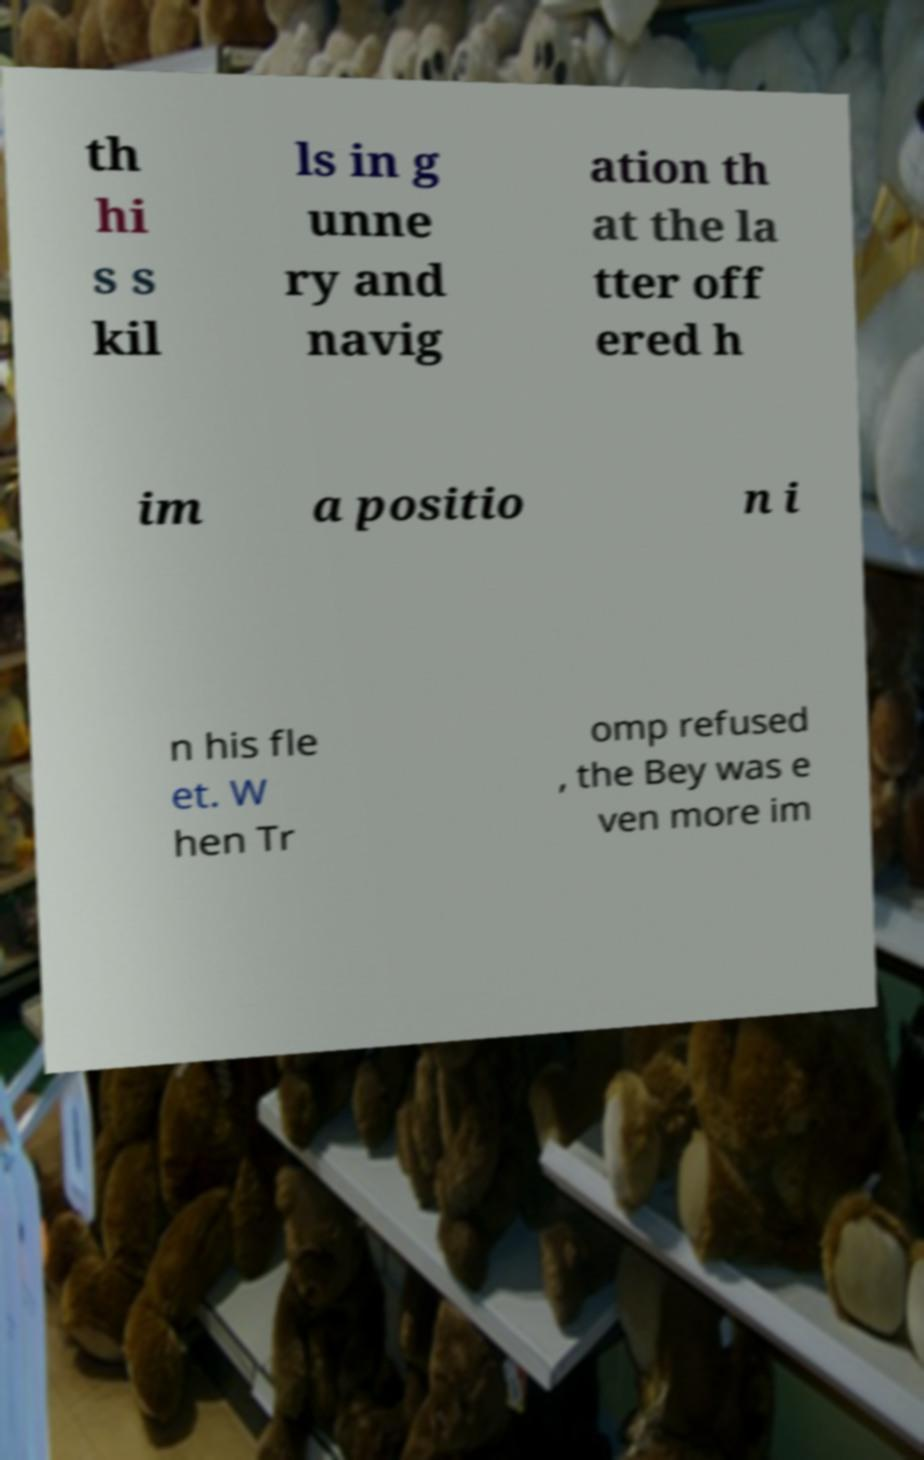Can you read and provide the text displayed in the image?This photo seems to have some interesting text. Can you extract and type it out for me? th hi s s kil ls in g unne ry and navig ation th at the la tter off ered h im a positio n i n his fle et. W hen Tr omp refused , the Bey was e ven more im 